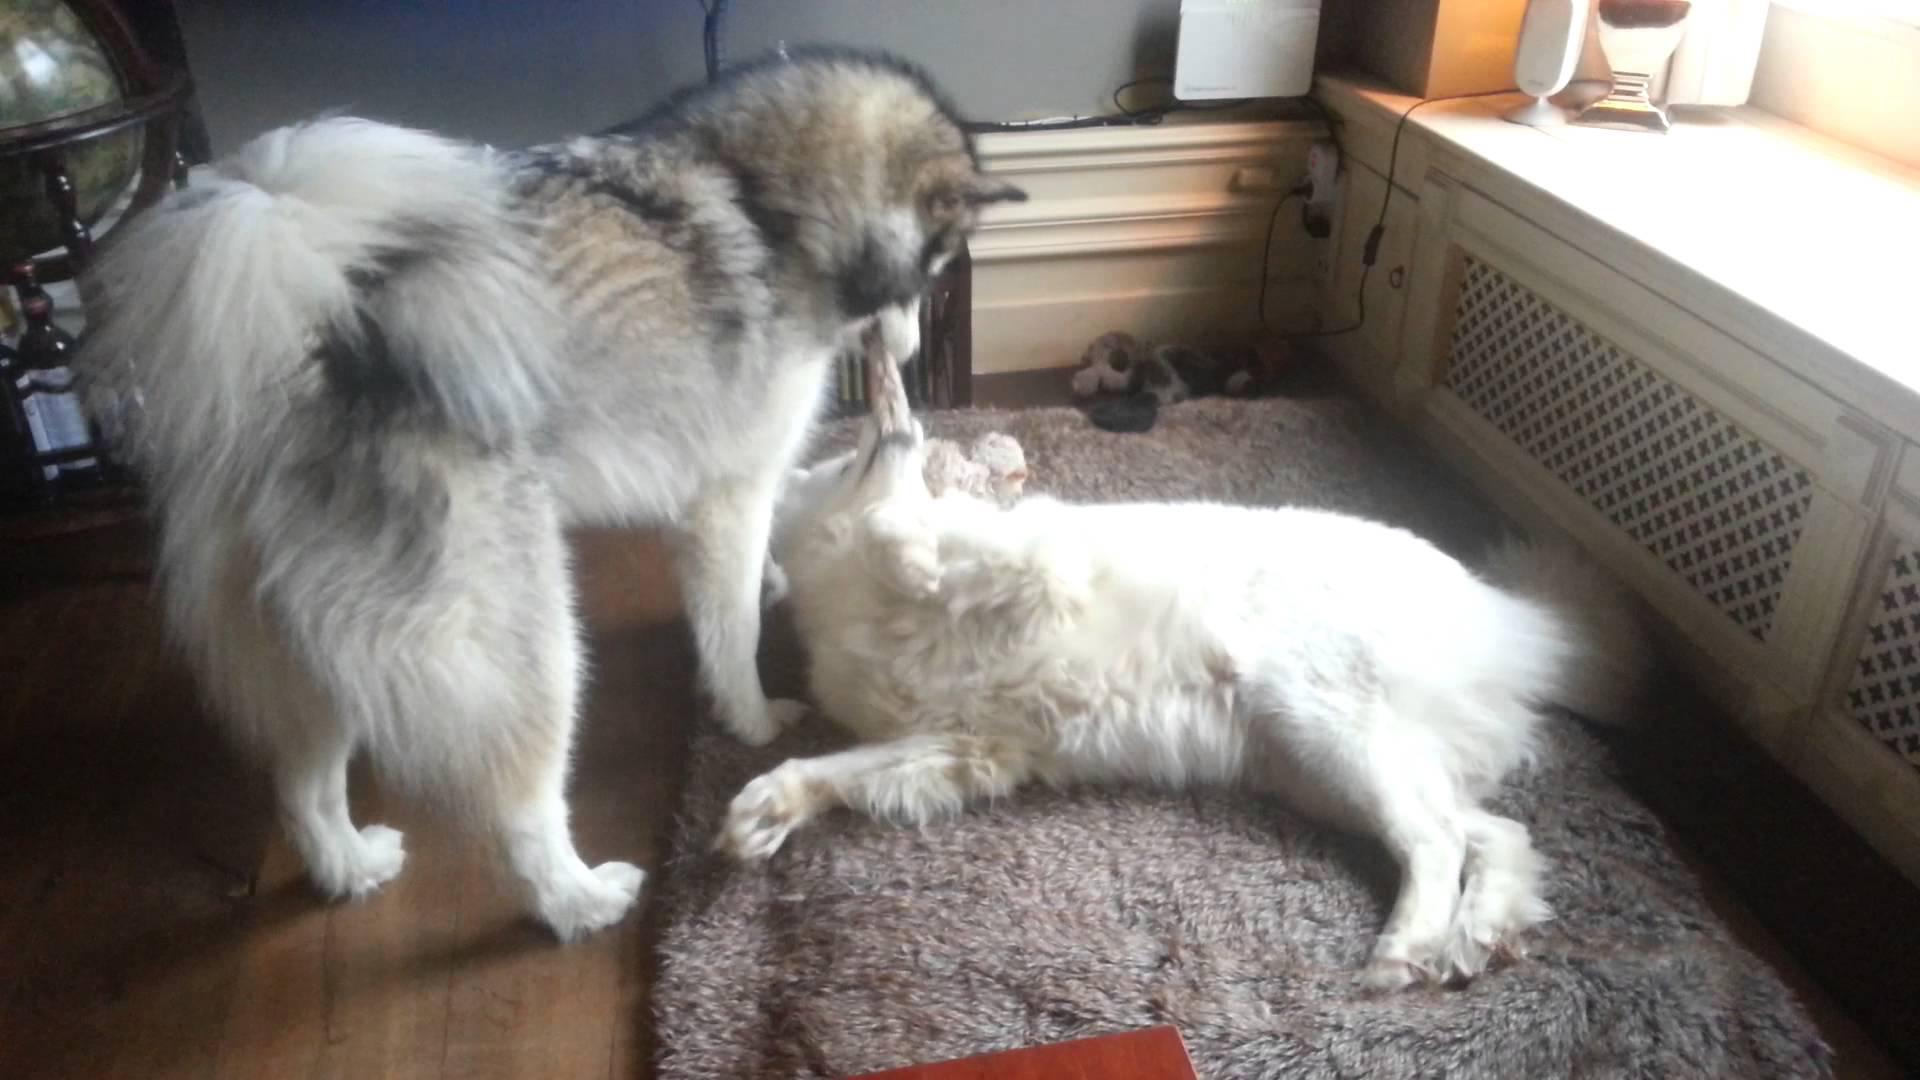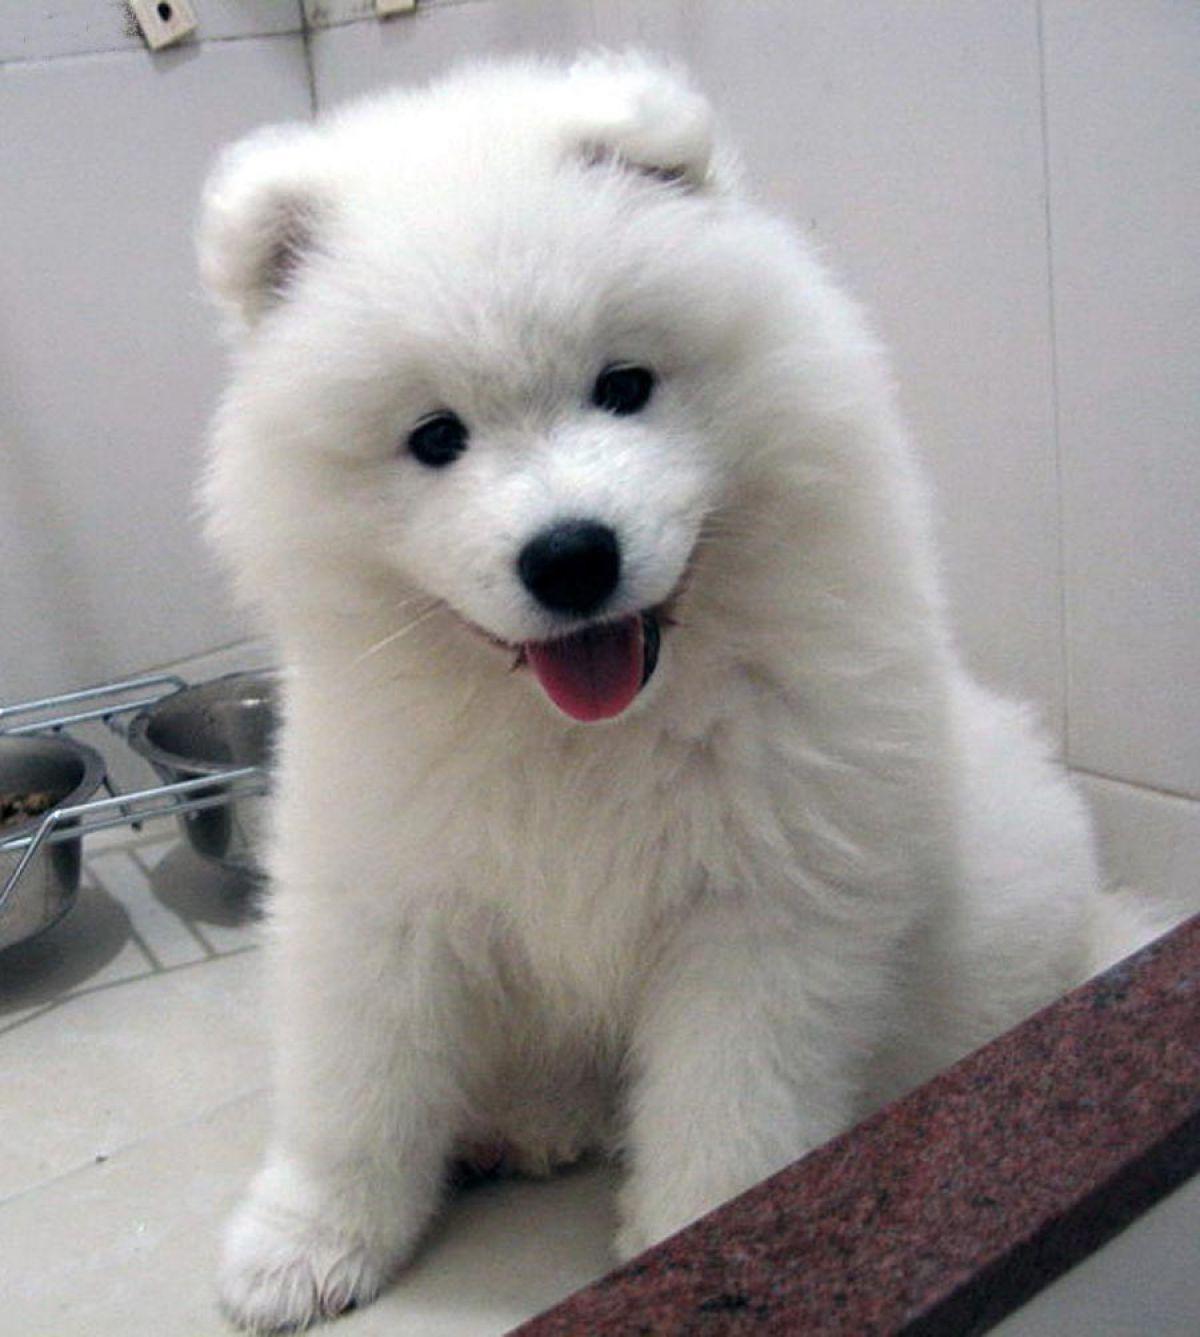The first image is the image on the left, the second image is the image on the right. Analyze the images presented: Is the assertion "One of the images shows exactly two dogs." valid? Answer yes or no. Yes. 